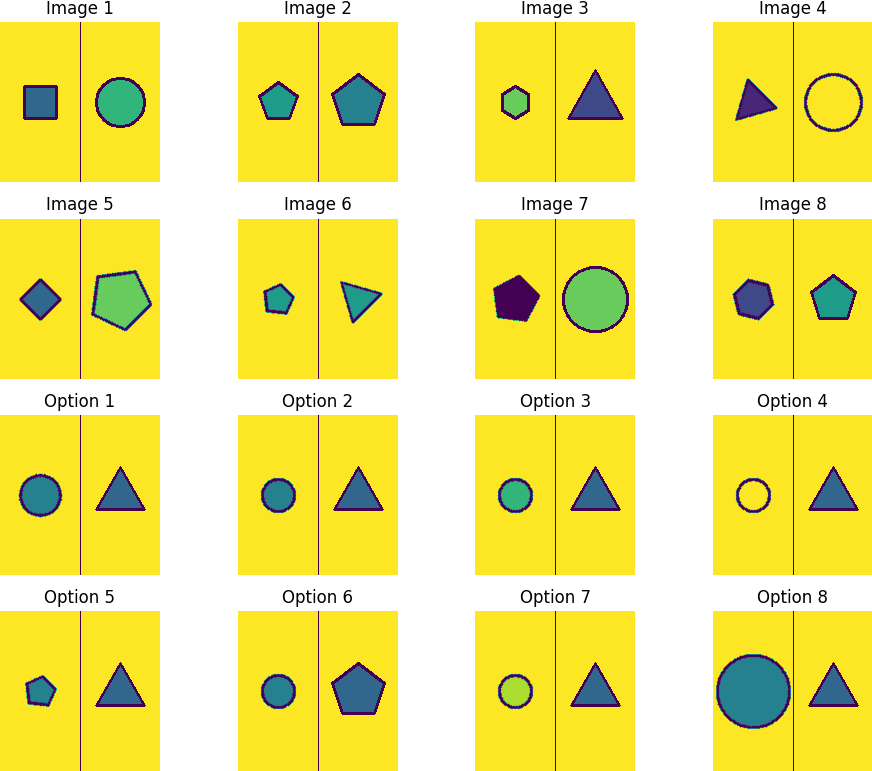What could the sequence of shapes signify in a broader symbolic context? The sequence of shapes, such as squares, circles, pentagons, and triangles, each represent different levels of complexity and stability. This could symbolize a progression or evolution in ideas or technology. For instance, the circle, often viewed as infinite and perfect in geometry, could represent continuity and completeness, contrasting with the square that embodies stability and balance. 